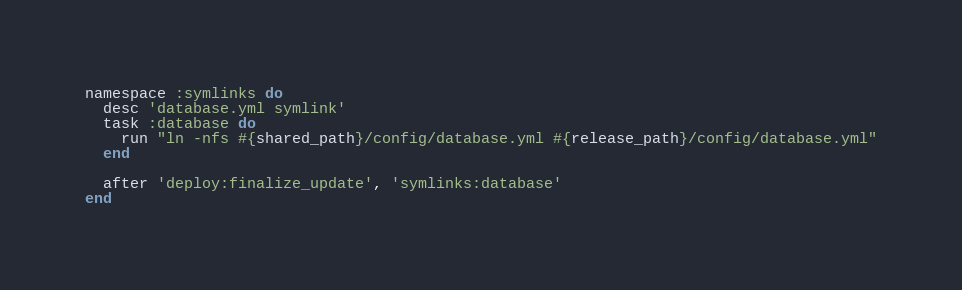<code> <loc_0><loc_0><loc_500><loc_500><_Ruby_>namespace :symlinks do
  desc 'database.yml symlink'
  task :database do
    run "ln -nfs #{shared_path}/config/database.yml #{release_path}/config/database.yml"
  end

  after 'deploy:finalize_update', 'symlinks:database'
end</code> 